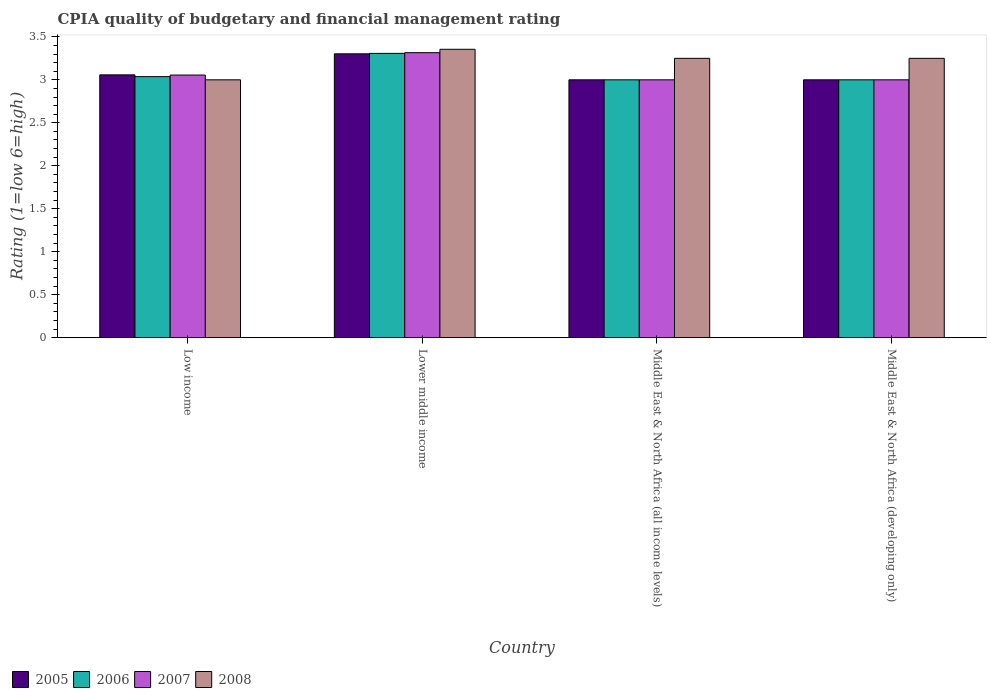How many groups of bars are there?
Your answer should be very brief. 4. Are the number of bars per tick equal to the number of legend labels?
Make the answer very short. Yes. Are the number of bars on each tick of the X-axis equal?
Provide a short and direct response. Yes. How many bars are there on the 2nd tick from the right?
Offer a terse response. 4. What is the label of the 3rd group of bars from the left?
Make the answer very short. Middle East & North Africa (all income levels). Across all countries, what is the maximum CPIA rating in 2006?
Your answer should be very brief. 3.31. In which country was the CPIA rating in 2007 maximum?
Offer a terse response. Lower middle income. In which country was the CPIA rating in 2007 minimum?
Ensure brevity in your answer.  Middle East & North Africa (all income levels). What is the total CPIA rating in 2008 in the graph?
Offer a very short reply. 12.86. What is the difference between the CPIA rating in 2006 in Lower middle income and that in Middle East & North Africa (developing only)?
Offer a terse response. 0.31. What is the difference between the CPIA rating in 2005 in Middle East & North Africa (developing only) and the CPIA rating in 2008 in Low income?
Provide a short and direct response. 0. What is the average CPIA rating in 2008 per country?
Provide a short and direct response. 3.21. What is the ratio of the CPIA rating in 2005 in Lower middle income to that in Middle East & North Africa (developing only)?
Your answer should be compact. 1.1. Is the CPIA rating in 2007 in Low income less than that in Middle East & North Africa (all income levels)?
Provide a short and direct response. No. What is the difference between the highest and the second highest CPIA rating in 2006?
Keep it short and to the point. 0.04. What is the difference between the highest and the lowest CPIA rating in 2008?
Offer a terse response. 0.36. What does the 1st bar from the left in Middle East & North Africa (developing only) represents?
Keep it short and to the point. 2005. Is it the case that in every country, the sum of the CPIA rating in 2008 and CPIA rating in 2005 is greater than the CPIA rating in 2007?
Provide a short and direct response. Yes. Are the values on the major ticks of Y-axis written in scientific E-notation?
Provide a succinct answer. No. What is the title of the graph?
Make the answer very short. CPIA quality of budgetary and financial management rating. Does "2002" appear as one of the legend labels in the graph?
Keep it short and to the point. No. What is the label or title of the X-axis?
Ensure brevity in your answer.  Country. What is the label or title of the Y-axis?
Offer a very short reply. Rating (1=low 6=high). What is the Rating (1=low 6=high) in 2005 in Low income?
Provide a succinct answer. 3.06. What is the Rating (1=low 6=high) in 2006 in Low income?
Your answer should be very brief. 3.04. What is the Rating (1=low 6=high) of 2007 in Low income?
Offer a very short reply. 3.06. What is the Rating (1=low 6=high) of 2008 in Low income?
Your answer should be very brief. 3. What is the Rating (1=low 6=high) of 2005 in Lower middle income?
Provide a succinct answer. 3.3. What is the Rating (1=low 6=high) in 2006 in Lower middle income?
Your answer should be very brief. 3.31. What is the Rating (1=low 6=high) in 2007 in Lower middle income?
Your answer should be very brief. 3.32. What is the Rating (1=low 6=high) in 2008 in Lower middle income?
Your response must be concise. 3.36. What is the Rating (1=low 6=high) in 2007 in Middle East & North Africa (all income levels)?
Provide a succinct answer. 3. What is the Rating (1=low 6=high) of 2008 in Middle East & North Africa (all income levels)?
Your answer should be compact. 3.25. What is the Rating (1=low 6=high) in 2005 in Middle East & North Africa (developing only)?
Offer a terse response. 3. What is the Rating (1=low 6=high) of 2008 in Middle East & North Africa (developing only)?
Your answer should be very brief. 3.25. Across all countries, what is the maximum Rating (1=low 6=high) in 2005?
Your answer should be very brief. 3.3. Across all countries, what is the maximum Rating (1=low 6=high) in 2006?
Provide a succinct answer. 3.31. Across all countries, what is the maximum Rating (1=low 6=high) of 2007?
Make the answer very short. 3.32. Across all countries, what is the maximum Rating (1=low 6=high) of 2008?
Your answer should be very brief. 3.36. Across all countries, what is the minimum Rating (1=low 6=high) in 2007?
Provide a short and direct response. 3. What is the total Rating (1=low 6=high) in 2005 in the graph?
Offer a terse response. 12.36. What is the total Rating (1=low 6=high) in 2006 in the graph?
Your answer should be compact. 12.34. What is the total Rating (1=low 6=high) in 2007 in the graph?
Make the answer very short. 12.37. What is the total Rating (1=low 6=high) of 2008 in the graph?
Provide a succinct answer. 12.86. What is the difference between the Rating (1=low 6=high) of 2005 in Low income and that in Lower middle income?
Provide a short and direct response. -0.24. What is the difference between the Rating (1=low 6=high) of 2006 in Low income and that in Lower middle income?
Offer a very short reply. -0.27. What is the difference between the Rating (1=low 6=high) in 2007 in Low income and that in Lower middle income?
Your answer should be compact. -0.26. What is the difference between the Rating (1=low 6=high) in 2008 in Low income and that in Lower middle income?
Provide a short and direct response. -0.36. What is the difference between the Rating (1=low 6=high) of 2005 in Low income and that in Middle East & North Africa (all income levels)?
Offer a very short reply. 0.06. What is the difference between the Rating (1=low 6=high) of 2006 in Low income and that in Middle East & North Africa (all income levels)?
Your answer should be very brief. 0.04. What is the difference between the Rating (1=low 6=high) of 2007 in Low income and that in Middle East & North Africa (all income levels)?
Your answer should be compact. 0.06. What is the difference between the Rating (1=low 6=high) of 2008 in Low income and that in Middle East & North Africa (all income levels)?
Your answer should be compact. -0.25. What is the difference between the Rating (1=low 6=high) of 2005 in Low income and that in Middle East & North Africa (developing only)?
Ensure brevity in your answer.  0.06. What is the difference between the Rating (1=low 6=high) of 2006 in Low income and that in Middle East & North Africa (developing only)?
Offer a very short reply. 0.04. What is the difference between the Rating (1=low 6=high) in 2007 in Low income and that in Middle East & North Africa (developing only)?
Offer a very short reply. 0.06. What is the difference between the Rating (1=low 6=high) in 2008 in Low income and that in Middle East & North Africa (developing only)?
Offer a very short reply. -0.25. What is the difference between the Rating (1=low 6=high) of 2005 in Lower middle income and that in Middle East & North Africa (all income levels)?
Make the answer very short. 0.3. What is the difference between the Rating (1=low 6=high) in 2006 in Lower middle income and that in Middle East & North Africa (all income levels)?
Give a very brief answer. 0.31. What is the difference between the Rating (1=low 6=high) in 2007 in Lower middle income and that in Middle East & North Africa (all income levels)?
Give a very brief answer. 0.32. What is the difference between the Rating (1=low 6=high) in 2008 in Lower middle income and that in Middle East & North Africa (all income levels)?
Make the answer very short. 0.11. What is the difference between the Rating (1=low 6=high) of 2005 in Lower middle income and that in Middle East & North Africa (developing only)?
Your answer should be very brief. 0.3. What is the difference between the Rating (1=low 6=high) in 2006 in Lower middle income and that in Middle East & North Africa (developing only)?
Your answer should be compact. 0.31. What is the difference between the Rating (1=low 6=high) of 2007 in Lower middle income and that in Middle East & North Africa (developing only)?
Your answer should be very brief. 0.32. What is the difference between the Rating (1=low 6=high) in 2008 in Lower middle income and that in Middle East & North Africa (developing only)?
Your answer should be very brief. 0.11. What is the difference between the Rating (1=low 6=high) of 2005 in Low income and the Rating (1=low 6=high) of 2006 in Lower middle income?
Provide a short and direct response. -0.25. What is the difference between the Rating (1=low 6=high) in 2005 in Low income and the Rating (1=low 6=high) in 2007 in Lower middle income?
Your answer should be very brief. -0.26. What is the difference between the Rating (1=low 6=high) of 2005 in Low income and the Rating (1=low 6=high) of 2008 in Lower middle income?
Your response must be concise. -0.3. What is the difference between the Rating (1=low 6=high) of 2006 in Low income and the Rating (1=low 6=high) of 2007 in Lower middle income?
Your answer should be compact. -0.28. What is the difference between the Rating (1=low 6=high) in 2006 in Low income and the Rating (1=low 6=high) in 2008 in Lower middle income?
Provide a succinct answer. -0.32. What is the difference between the Rating (1=low 6=high) of 2007 in Low income and the Rating (1=low 6=high) of 2008 in Lower middle income?
Your response must be concise. -0.3. What is the difference between the Rating (1=low 6=high) of 2005 in Low income and the Rating (1=low 6=high) of 2006 in Middle East & North Africa (all income levels)?
Give a very brief answer. 0.06. What is the difference between the Rating (1=low 6=high) of 2005 in Low income and the Rating (1=low 6=high) of 2007 in Middle East & North Africa (all income levels)?
Ensure brevity in your answer.  0.06. What is the difference between the Rating (1=low 6=high) in 2005 in Low income and the Rating (1=low 6=high) in 2008 in Middle East & North Africa (all income levels)?
Provide a succinct answer. -0.19. What is the difference between the Rating (1=low 6=high) of 2006 in Low income and the Rating (1=low 6=high) of 2007 in Middle East & North Africa (all income levels)?
Your answer should be compact. 0.04. What is the difference between the Rating (1=low 6=high) in 2006 in Low income and the Rating (1=low 6=high) in 2008 in Middle East & North Africa (all income levels)?
Your answer should be very brief. -0.21. What is the difference between the Rating (1=low 6=high) of 2007 in Low income and the Rating (1=low 6=high) of 2008 in Middle East & North Africa (all income levels)?
Offer a terse response. -0.19. What is the difference between the Rating (1=low 6=high) of 2005 in Low income and the Rating (1=low 6=high) of 2006 in Middle East & North Africa (developing only)?
Your answer should be very brief. 0.06. What is the difference between the Rating (1=low 6=high) of 2005 in Low income and the Rating (1=low 6=high) of 2007 in Middle East & North Africa (developing only)?
Your answer should be compact. 0.06. What is the difference between the Rating (1=low 6=high) in 2005 in Low income and the Rating (1=low 6=high) in 2008 in Middle East & North Africa (developing only)?
Offer a terse response. -0.19. What is the difference between the Rating (1=low 6=high) in 2006 in Low income and the Rating (1=low 6=high) in 2007 in Middle East & North Africa (developing only)?
Your response must be concise. 0.04. What is the difference between the Rating (1=low 6=high) in 2006 in Low income and the Rating (1=low 6=high) in 2008 in Middle East & North Africa (developing only)?
Make the answer very short. -0.21. What is the difference between the Rating (1=low 6=high) of 2007 in Low income and the Rating (1=low 6=high) of 2008 in Middle East & North Africa (developing only)?
Your answer should be very brief. -0.19. What is the difference between the Rating (1=low 6=high) of 2005 in Lower middle income and the Rating (1=low 6=high) of 2006 in Middle East & North Africa (all income levels)?
Offer a very short reply. 0.3. What is the difference between the Rating (1=low 6=high) of 2005 in Lower middle income and the Rating (1=low 6=high) of 2007 in Middle East & North Africa (all income levels)?
Ensure brevity in your answer.  0.3. What is the difference between the Rating (1=low 6=high) in 2005 in Lower middle income and the Rating (1=low 6=high) in 2008 in Middle East & North Africa (all income levels)?
Ensure brevity in your answer.  0.05. What is the difference between the Rating (1=low 6=high) of 2006 in Lower middle income and the Rating (1=low 6=high) of 2007 in Middle East & North Africa (all income levels)?
Offer a very short reply. 0.31. What is the difference between the Rating (1=low 6=high) in 2006 in Lower middle income and the Rating (1=low 6=high) in 2008 in Middle East & North Africa (all income levels)?
Your answer should be compact. 0.06. What is the difference between the Rating (1=low 6=high) of 2007 in Lower middle income and the Rating (1=low 6=high) of 2008 in Middle East & North Africa (all income levels)?
Keep it short and to the point. 0.07. What is the difference between the Rating (1=low 6=high) of 2005 in Lower middle income and the Rating (1=low 6=high) of 2006 in Middle East & North Africa (developing only)?
Keep it short and to the point. 0.3. What is the difference between the Rating (1=low 6=high) in 2005 in Lower middle income and the Rating (1=low 6=high) in 2007 in Middle East & North Africa (developing only)?
Keep it short and to the point. 0.3. What is the difference between the Rating (1=low 6=high) in 2005 in Lower middle income and the Rating (1=low 6=high) in 2008 in Middle East & North Africa (developing only)?
Your answer should be compact. 0.05. What is the difference between the Rating (1=low 6=high) of 2006 in Lower middle income and the Rating (1=low 6=high) of 2007 in Middle East & North Africa (developing only)?
Your response must be concise. 0.31. What is the difference between the Rating (1=low 6=high) in 2006 in Lower middle income and the Rating (1=low 6=high) in 2008 in Middle East & North Africa (developing only)?
Offer a very short reply. 0.06. What is the difference between the Rating (1=low 6=high) of 2007 in Lower middle income and the Rating (1=low 6=high) of 2008 in Middle East & North Africa (developing only)?
Give a very brief answer. 0.07. What is the difference between the Rating (1=low 6=high) in 2005 in Middle East & North Africa (all income levels) and the Rating (1=low 6=high) in 2006 in Middle East & North Africa (developing only)?
Give a very brief answer. 0. What is the difference between the Rating (1=low 6=high) in 2005 in Middle East & North Africa (all income levels) and the Rating (1=low 6=high) in 2008 in Middle East & North Africa (developing only)?
Your response must be concise. -0.25. What is the difference between the Rating (1=low 6=high) of 2006 in Middle East & North Africa (all income levels) and the Rating (1=low 6=high) of 2008 in Middle East & North Africa (developing only)?
Keep it short and to the point. -0.25. What is the difference between the Rating (1=low 6=high) in 2007 in Middle East & North Africa (all income levels) and the Rating (1=low 6=high) in 2008 in Middle East & North Africa (developing only)?
Ensure brevity in your answer.  -0.25. What is the average Rating (1=low 6=high) in 2005 per country?
Ensure brevity in your answer.  3.09. What is the average Rating (1=low 6=high) in 2006 per country?
Give a very brief answer. 3.09. What is the average Rating (1=low 6=high) in 2007 per country?
Make the answer very short. 3.09. What is the average Rating (1=low 6=high) of 2008 per country?
Your answer should be very brief. 3.21. What is the difference between the Rating (1=low 6=high) of 2005 and Rating (1=low 6=high) of 2006 in Low income?
Give a very brief answer. 0.02. What is the difference between the Rating (1=low 6=high) of 2005 and Rating (1=low 6=high) of 2007 in Low income?
Ensure brevity in your answer.  0. What is the difference between the Rating (1=low 6=high) of 2005 and Rating (1=low 6=high) of 2008 in Low income?
Your answer should be very brief. 0.06. What is the difference between the Rating (1=low 6=high) in 2006 and Rating (1=low 6=high) in 2007 in Low income?
Offer a terse response. -0.02. What is the difference between the Rating (1=low 6=high) of 2006 and Rating (1=low 6=high) of 2008 in Low income?
Offer a terse response. 0.04. What is the difference between the Rating (1=low 6=high) of 2007 and Rating (1=low 6=high) of 2008 in Low income?
Provide a short and direct response. 0.06. What is the difference between the Rating (1=low 6=high) of 2005 and Rating (1=low 6=high) of 2006 in Lower middle income?
Your response must be concise. -0.01. What is the difference between the Rating (1=low 6=high) in 2005 and Rating (1=low 6=high) in 2007 in Lower middle income?
Provide a short and direct response. -0.01. What is the difference between the Rating (1=low 6=high) in 2005 and Rating (1=low 6=high) in 2008 in Lower middle income?
Make the answer very short. -0.05. What is the difference between the Rating (1=low 6=high) of 2006 and Rating (1=low 6=high) of 2007 in Lower middle income?
Offer a terse response. -0.01. What is the difference between the Rating (1=low 6=high) in 2006 and Rating (1=low 6=high) in 2008 in Lower middle income?
Provide a succinct answer. -0.05. What is the difference between the Rating (1=low 6=high) in 2007 and Rating (1=low 6=high) in 2008 in Lower middle income?
Provide a short and direct response. -0.04. What is the difference between the Rating (1=low 6=high) in 2005 and Rating (1=low 6=high) in 2007 in Middle East & North Africa (all income levels)?
Keep it short and to the point. 0. What is the difference between the Rating (1=low 6=high) of 2006 and Rating (1=low 6=high) of 2007 in Middle East & North Africa (all income levels)?
Provide a short and direct response. 0. What is the difference between the Rating (1=low 6=high) in 2007 and Rating (1=low 6=high) in 2008 in Middle East & North Africa (all income levels)?
Provide a succinct answer. -0.25. What is the difference between the Rating (1=low 6=high) of 2005 and Rating (1=low 6=high) of 2006 in Middle East & North Africa (developing only)?
Your response must be concise. 0. What is the difference between the Rating (1=low 6=high) of 2005 and Rating (1=low 6=high) of 2007 in Middle East & North Africa (developing only)?
Provide a succinct answer. 0. What is the difference between the Rating (1=low 6=high) of 2006 and Rating (1=low 6=high) of 2007 in Middle East & North Africa (developing only)?
Ensure brevity in your answer.  0. What is the difference between the Rating (1=low 6=high) in 2006 and Rating (1=low 6=high) in 2008 in Middle East & North Africa (developing only)?
Give a very brief answer. -0.25. What is the ratio of the Rating (1=low 6=high) in 2005 in Low income to that in Lower middle income?
Offer a very short reply. 0.93. What is the ratio of the Rating (1=low 6=high) in 2006 in Low income to that in Lower middle income?
Ensure brevity in your answer.  0.92. What is the ratio of the Rating (1=low 6=high) of 2007 in Low income to that in Lower middle income?
Provide a short and direct response. 0.92. What is the ratio of the Rating (1=low 6=high) in 2008 in Low income to that in Lower middle income?
Ensure brevity in your answer.  0.89. What is the ratio of the Rating (1=low 6=high) in 2005 in Low income to that in Middle East & North Africa (all income levels)?
Ensure brevity in your answer.  1.02. What is the ratio of the Rating (1=low 6=high) in 2006 in Low income to that in Middle East & North Africa (all income levels)?
Keep it short and to the point. 1.01. What is the ratio of the Rating (1=low 6=high) of 2007 in Low income to that in Middle East & North Africa (all income levels)?
Provide a short and direct response. 1.02. What is the ratio of the Rating (1=low 6=high) of 2008 in Low income to that in Middle East & North Africa (all income levels)?
Ensure brevity in your answer.  0.92. What is the ratio of the Rating (1=low 6=high) of 2005 in Low income to that in Middle East & North Africa (developing only)?
Keep it short and to the point. 1.02. What is the ratio of the Rating (1=low 6=high) in 2006 in Low income to that in Middle East & North Africa (developing only)?
Keep it short and to the point. 1.01. What is the ratio of the Rating (1=low 6=high) in 2007 in Low income to that in Middle East & North Africa (developing only)?
Your answer should be compact. 1.02. What is the ratio of the Rating (1=low 6=high) in 2005 in Lower middle income to that in Middle East & North Africa (all income levels)?
Your answer should be compact. 1.1. What is the ratio of the Rating (1=low 6=high) of 2006 in Lower middle income to that in Middle East & North Africa (all income levels)?
Make the answer very short. 1.1. What is the ratio of the Rating (1=low 6=high) in 2007 in Lower middle income to that in Middle East & North Africa (all income levels)?
Your answer should be very brief. 1.11. What is the ratio of the Rating (1=low 6=high) of 2008 in Lower middle income to that in Middle East & North Africa (all income levels)?
Offer a terse response. 1.03. What is the ratio of the Rating (1=low 6=high) of 2005 in Lower middle income to that in Middle East & North Africa (developing only)?
Keep it short and to the point. 1.1. What is the ratio of the Rating (1=low 6=high) of 2006 in Lower middle income to that in Middle East & North Africa (developing only)?
Offer a very short reply. 1.1. What is the ratio of the Rating (1=low 6=high) of 2007 in Lower middle income to that in Middle East & North Africa (developing only)?
Give a very brief answer. 1.11. What is the ratio of the Rating (1=low 6=high) of 2008 in Lower middle income to that in Middle East & North Africa (developing only)?
Keep it short and to the point. 1.03. What is the ratio of the Rating (1=low 6=high) in 2007 in Middle East & North Africa (all income levels) to that in Middle East & North Africa (developing only)?
Your answer should be very brief. 1. What is the difference between the highest and the second highest Rating (1=low 6=high) of 2005?
Your answer should be compact. 0.24. What is the difference between the highest and the second highest Rating (1=low 6=high) of 2006?
Your answer should be compact. 0.27. What is the difference between the highest and the second highest Rating (1=low 6=high) of 2007?
Provide a succinct answer. 0.26. What is the difference between the highest and the second highest Rating (1=low 6=high) in 2008?
Offer a very short reply. 0.11. What is the difference between the highest and the lowest Rating (1=low 6=high) in 2005?
Offer a very short reply. 0.3. What is the difference between the highest and the lowest Rating (1=low 6=high) in 2006?
Your response must be concise. 0.31. What is the difference between the highest and the lowest Rating (1=low 6=high) of 2007?
Your response must be concise. 0.32. What is the difference between the highest and the lowest Rating (1=low 6=high) in 2008?
Offer a very short reply. 0.36. 